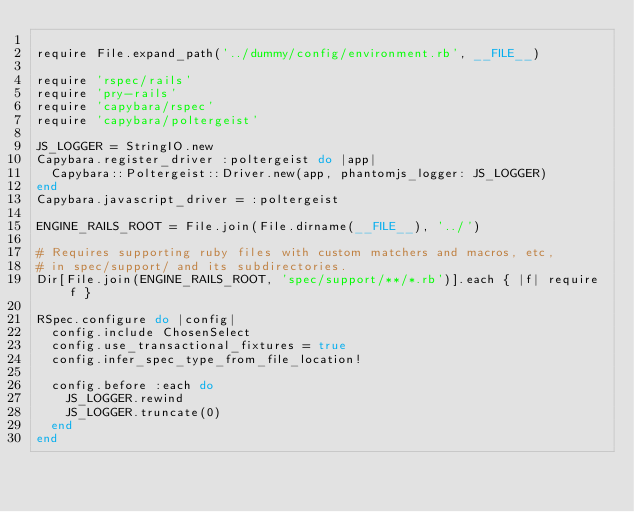<code> <loc_0><loc_0><loc_500><loc_500><_Ruby_>
require File.expand_path('../dummy/config/environment.rb', __FILE__)

require 'rspec/rails'
require 'pry-rails'
require 'capybara/rspec'
require 'capybara/poltergeist'

JS_LOGGER = StringIO.new
Capybara.register_driver :poltergeist do |app|
  Capybara::Poltergeist::Driver.new(app, phantomjs_logger: JS_LOGGER)
end
Capybara.javascript_driver = :poltergeist

ENGINE_RAILS_ROOT = File.join(File.dirname(__FILE__), '../')

# Requires supporting ruby files with custom matchers and macros, etc,
# in spec/support/ and its subdirectories.
Dir[File.join(ENGINE_RAILS_ROOT, 'spec/support/**/*.rb')].each { |f| require f }

RSpec.configure do |config|
  config.include ChosenSelect
  config.use_transactional_fixtures = true
  config.infer_spec_type_from_file_location!

  config.before :each do
    JS_LOGGER.rewind
    JS_LOGGER.truncate(0)
  end
end
</code> 